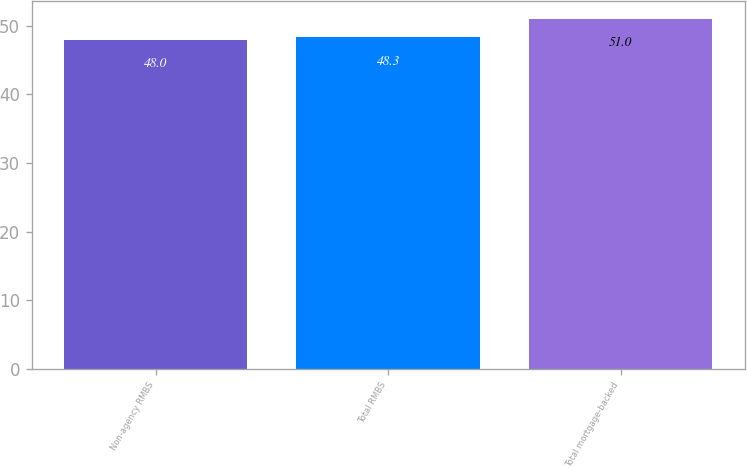<chart> <loc_0><loc_0><loc_500><loc_500><bar_chart><fcel>Non-agency RMBS<fcel>Total RMBS<fcel>Total mortgage-backed<nl><fcel>48<fcel>48.3<fcel>51<nl></chart> 